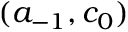Convert formula to latex. <formula><loc_0><loc_0><loc_500><loc_500>( a _ { - 1 } , c _ { 0 } )</formula> 